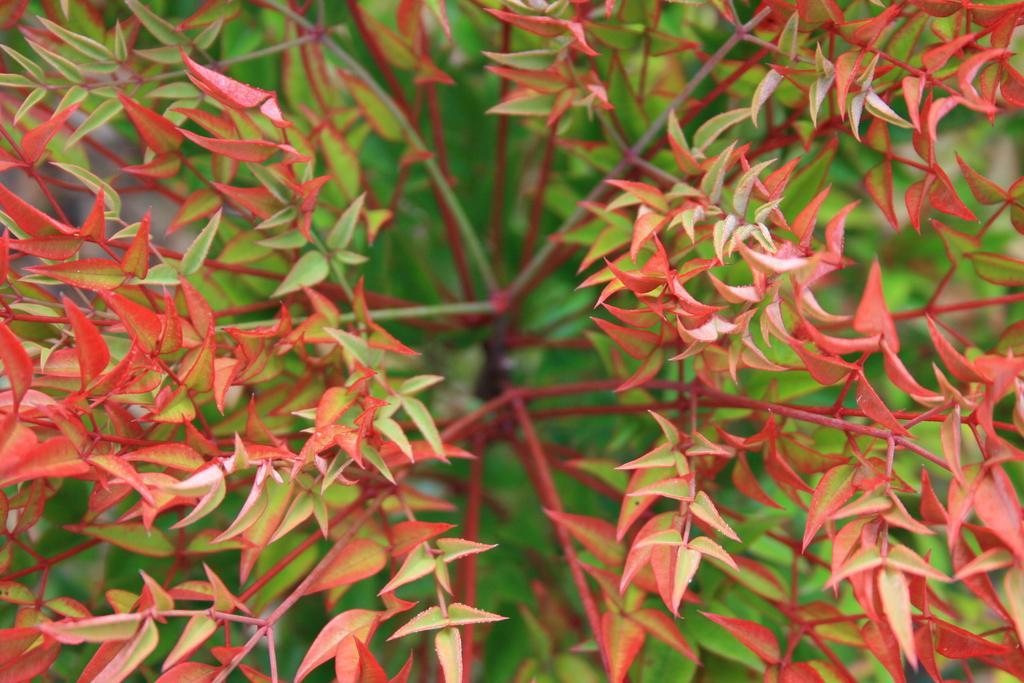Could you give a brief overview of what you see in this image? In this picture we can see an orange and green color leaves of the plant. 